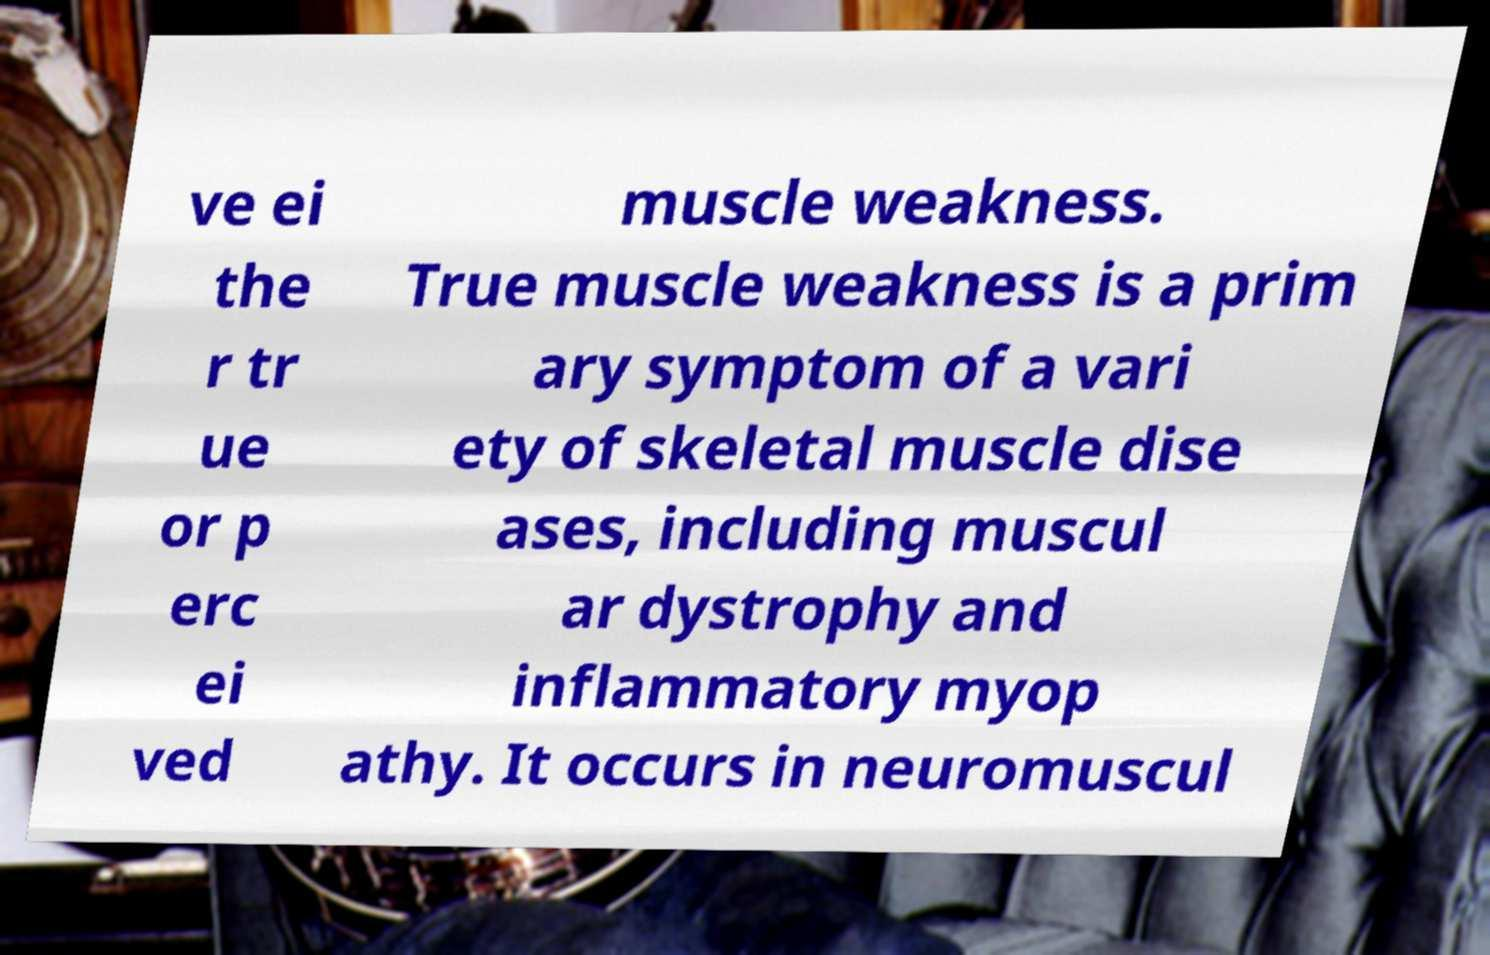Please read and relay the text visible in this image. What does it say? ve ei the r tr ue or p erc ei ved muscle weakness. True muscle weakness is a prim ary symptom of a vari ety of skeletal muscle dise ases, including muscul ar dystrophy and inflammatory myop athy. It occurs in neuromuscul 